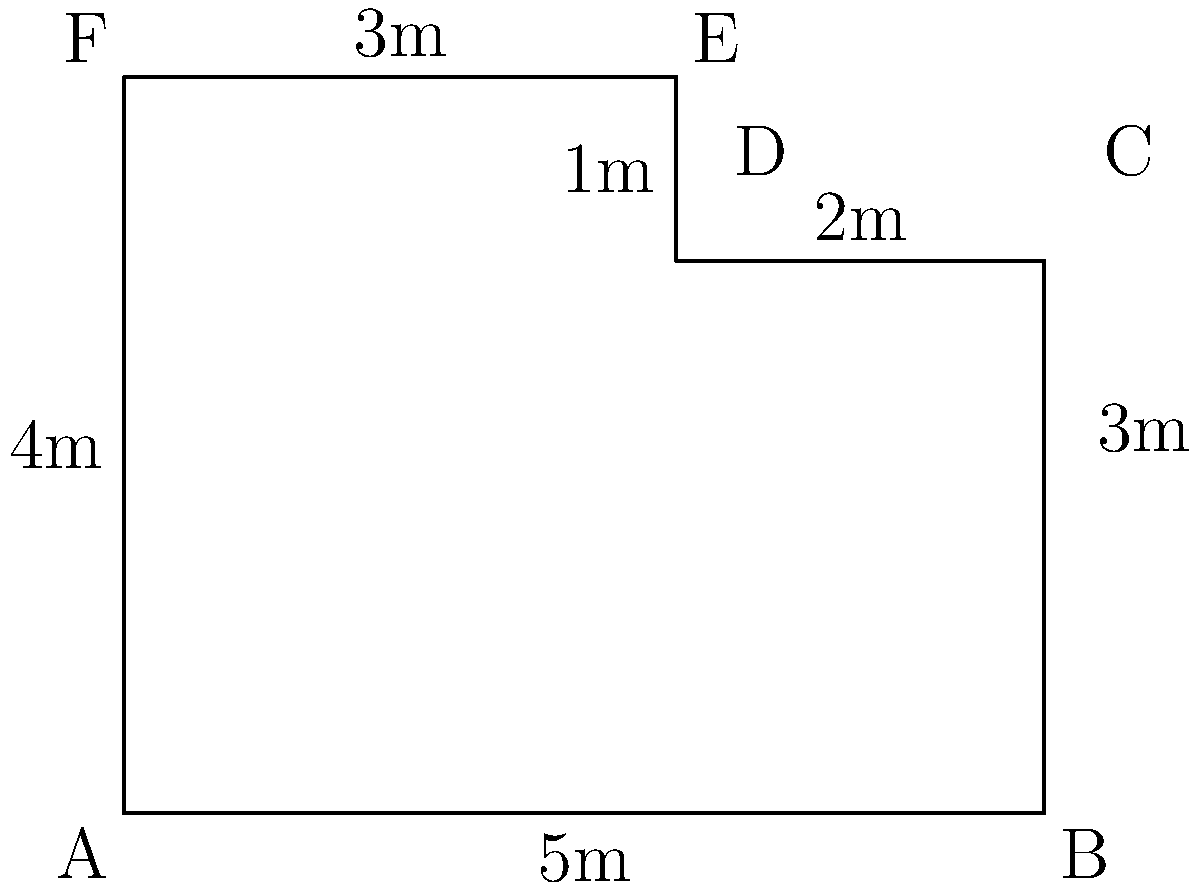A community garden plot has an irregular shape as shown in the diagram. Calculate the perimeter of this garden plot in meters. To calculate the perimeter of the irregularly shaped community garden plot, we need to sum up the lengths of all sides:

1. Side AB: $5$ meters
2. Side BC: $3$ meters
3. Side CD: $2$ meters
4. Side DE: $1$ meter
5. Side EF: $3$ meters
6. Side FA: $4$ meters

Now, let's add up all these lengths:

$$\text{Perimeter} = 5 + 3 + 2 + 1 + 3 + 4 = 18$$

Therefore, the perimeter of the community garden plot is 18 meters.
Answer: 18 meters 